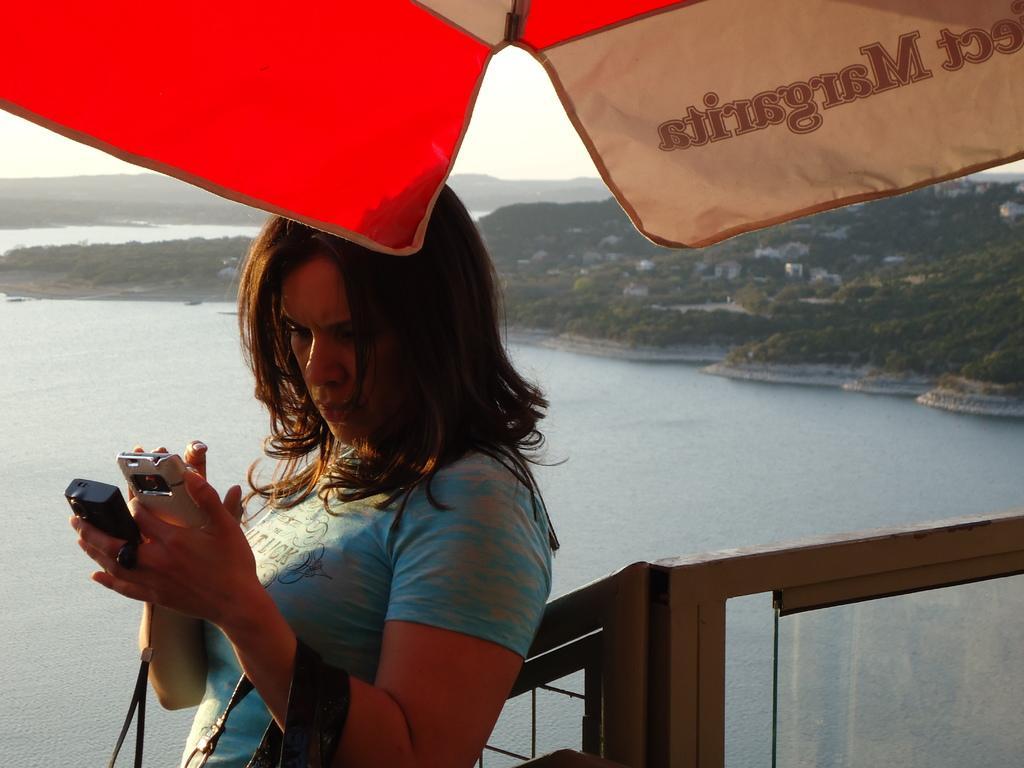Please provide a concise description of this image. In the picture we can see a woman standing near the railing wearing a blue T-shirt and holding a mobile phone in the hand and behind her we can see a river with a hill beside it with grass, plants, trees and sky. 